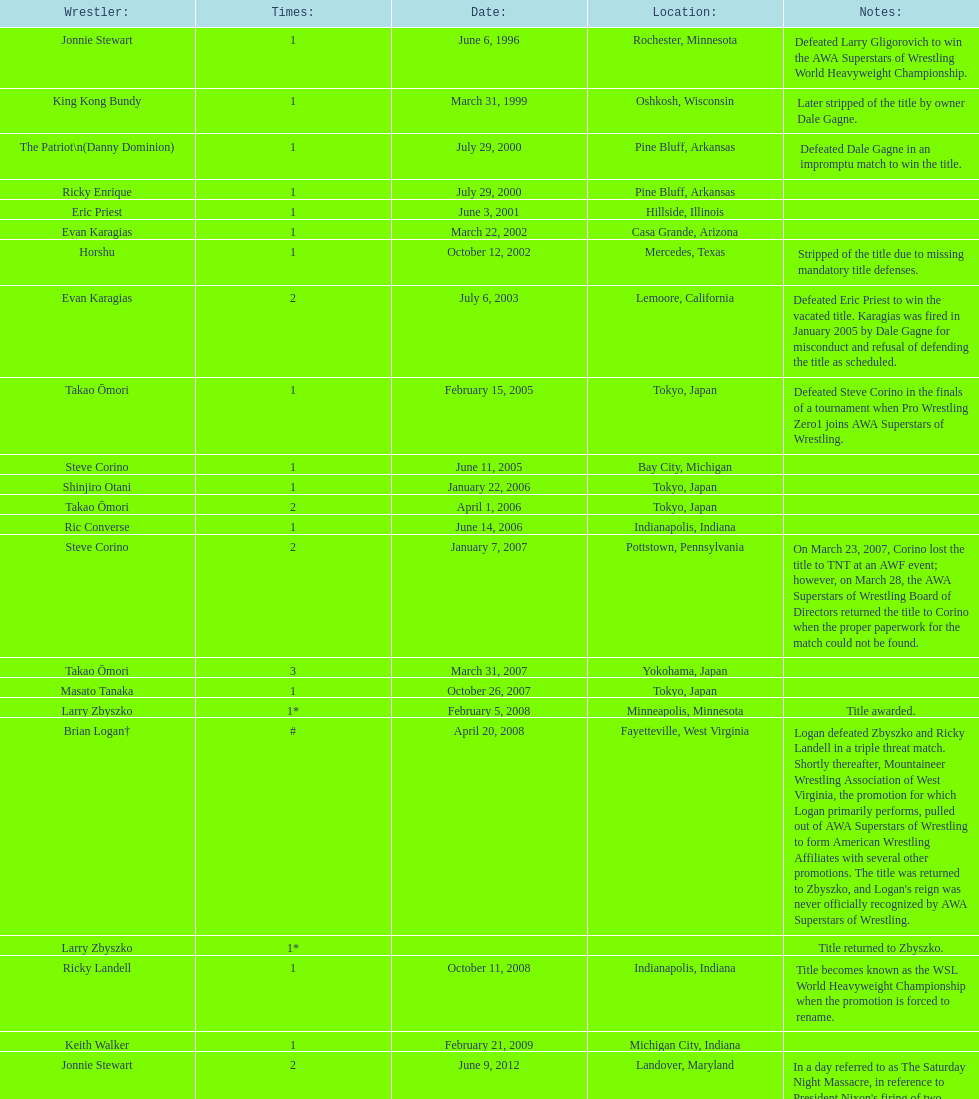The wsl title has been won by ricky landell how many times? 1. 